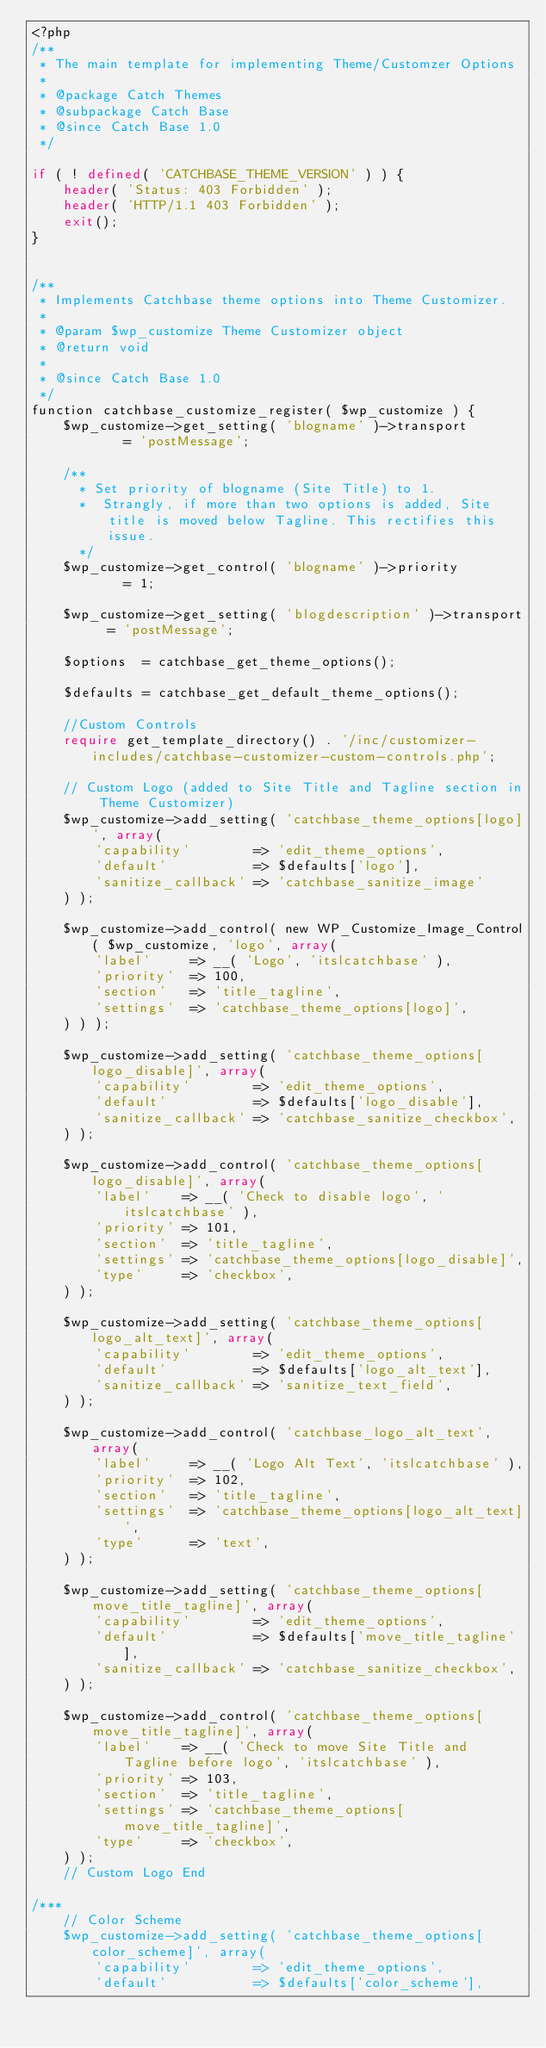Convert code to text. <code><loc_0><loc_0><loc_500><loc_500><_PHP_><?php
/**
 * The main template for implementing Theme/Customzer Options
 *
 * @package Catch Themes
 * @subpackage Catch Base
 * @since Catch Base 1.0 
 */

if ( ! defined( 'CATCHBASE_THEME_VERSION' ) ) {
	header( 'Status: 403 Forbidden' );
	header( 'HTTP/1.1 403 Forbidden' );
	exit();
}


/**
 * Implements Catchbase theme options into Theme Customizer.
 *
 * @param $wp_customize Theme Customizer object
 * @return void
 *
 * @since Catch Base 1.0
 */
function catchbase_customize_register( $wp_customize ) {
	$wp_customize->get_setting( 'blogname' )->transport			= 'postMessage';

	/**
	  * Set priority of blogname (Site Title) to 1. 
	  *  Strangly, if more than two options is added, Site title is moved below Tagline. This rectifies this issue.
	  */
	$wp_customize->get_control( 'blogname' )->priority			= 1;

	$wp_customize->get_setting( 'blogdescription' )->transport	= 'postMessage';

	$options  = catchbase_get_theme_options();

	$defaults = catchbase_get_default_theme_options();

	//Custom Controls
	require get_template_directory() . '/inc/customizer-includes/catchbase-customizer-custom-controls.php';

	// Custom Logo (added to Site Title and Tagline section in Theme Customizer)
	$wp_customize->add_setting( 'catchbase_theme_options[logo]', array(
		'capability'		=> 'edit_theme_options',
		'default'			=> $defaults['logo'],
		'sanitize_callback'	=> 'catchbase_sanitize_image'
	) );

	$wp_customize->add_control( new WP_Customize_Image_Control( $wp_customize, 'logo', array(
		'label'		=> __( 'Logo', 'itslcatchbase' ),
		'priority'	=> 100,
		'section'   => 'title_tagline',
        'settings'  => 'catchbase_theme_options[logo]',
    ) ) );

    $wp_customize->add_setting( 'catchbase_theme_options[logo_disable]', array(
		'capability'		=> 'edit_theme_options',
		'default'			=> $defaults['logo_disable'],
		'sanitize_callback' => 'catchbase_sanitize_checkbox',
	) );

	$wp_customize->add_control( 'catchbase_theme_options[logo_disable]', array(
		'label'    => __( 'Check to disable logo', 'itslcatchbase' ),
		'priority' => 101,
		'section'  => 'title_tagline',
		'settings' => 'catchbase_theme_options[logo_disable]',
		'type'     => 'checkbox',
	) );
	
	$wp_customize->add_setting( 'catchbase_theme_options[logo_alt_text]', array(
		'capability'		=> 'edit_theme_options',
		'default'			=> $defaults['logo_alt_text'],
		'sanitize_callback'	=> 'sanitize_text_field',
	) );

	$wp_customize->add_control( 'catchbase_logo_alt_text', array(
		'label'    	=> __( 'Logo Alt Text', 'itslcatchbase' ),
		'priority'	=> 102,
		'section' 	=> 'title_tagline',
		'settings' 	=> 'catchbase_theme_options[logo_alt_text]',
		'type'     	=> 'text',
	) );

	$wp_customize->add_setting( 'catchbase_theme_options[move_title_tagline]', array(
		'capability'		=> 'edit_theme_options',
		'default'			=> $defaults['move_title_tagline'],
		'sanitize_callback' => 'catchbase_sanitize_checkbox',
	) );

	$wp_customize->add_control( 'catchbase_theme_options[move_title_tagline]', array(
		'label'    => __( 'Check to move Site Title and Tagline before logo', 'itslcatchbase' ),
		'priority' => 103,
		'section'  => 'title_tagline',
		'settings' => 'catchbase_theme_options[move_title_tagline]',
		'type'     => 'checkbox',
	) );
	// Custom Logo End

/***	 
	// Color Scheme
	$wp_customize->add_setting( 'catchbase_theme_options[color_scheme]', array(
		'capability' 		=> 'edit_theme_options',
		'default'    		=> $defaults['color_scheme'],</code> 